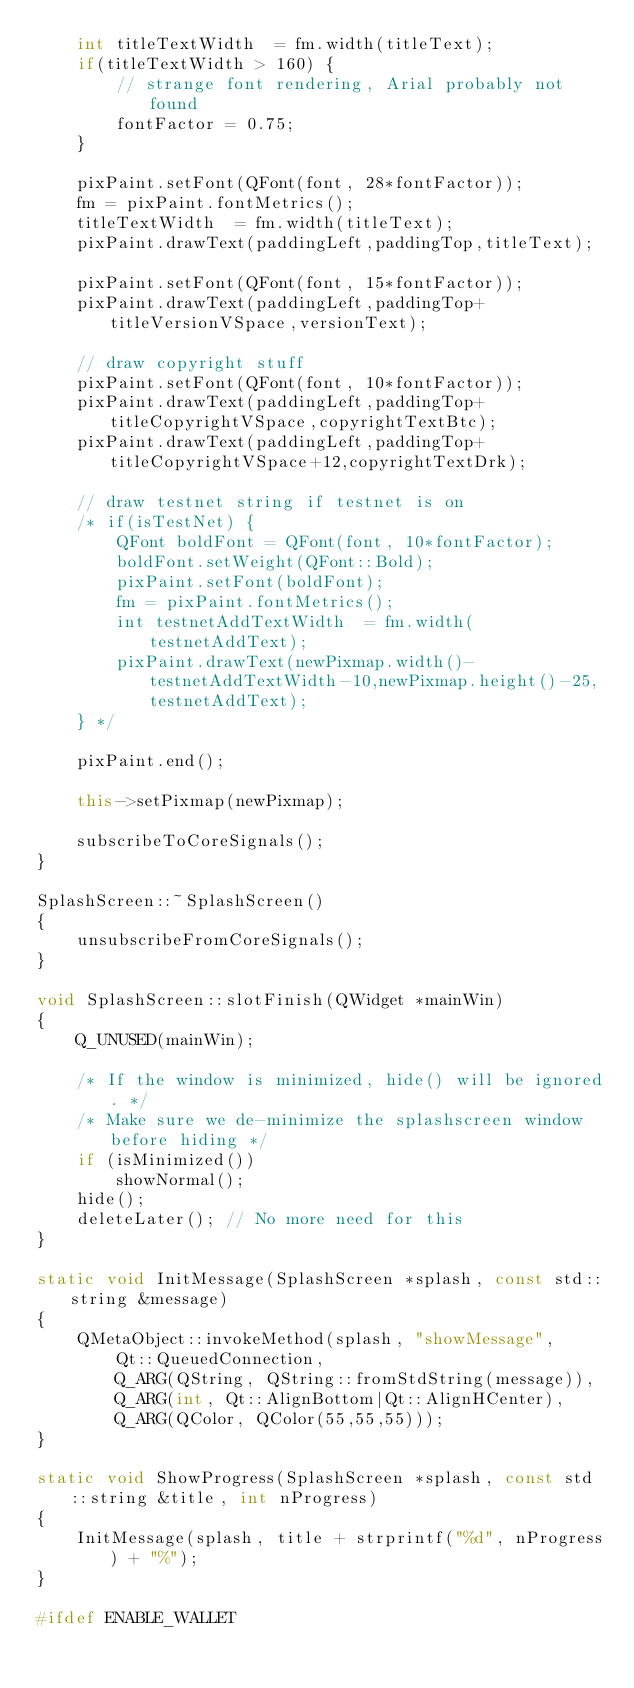<code> <loc_0><loc_0><loc_500><loc_500><_C++_>    int titleTextWidth  = fm.width(titleText);
    if(titleTextWidth > 160) {
        // strange font rendering, Arial probably not found
        fontFactor = 0.75;
    }

    pixPaint.setFont(QFont(font, 28*fontFactor));
    fm = pixPaint.fontMetrics();
    titleTextWidth  = fm.width(titleText);
    pixPaint.drawText(paddingLeft,paddingTop,titleText);

    pixPaint.setFont(QFont(font, 15*fontFactor));
    pixPaint.drawText(paddingLeft,paddingTop+titleVersionVSpace,versionText);

    // draw copyright stuff
    pixPaint.setFont(QFont(font, 10*fontFactor));
    pixPaint.drawText(paddingLeft,paddingTop+titleCopyrightVSpace,copyrightTextBtc);
    pixPaint.drawText(paddingLeft,paddingTop+titleCopyrightVSpace+12,copyrightTextDrk);

    // draw testnet string if testnet is on
    /* if(isTestNet) {
        QFont boldFont = QFont(font, 10*fontFactor);
        boldFont.setWeight(QFont::Bold);
        pixPaint.setFont(boldFont);
        fm = pixPaint.fontMetrics();
        int testnetAddTextWidth  = fm.width(testnetAddText);
        pixPaint.drawText(newPixmap.width()-testnetAddTextWidth-10,newPixmap.height()-25,testnetAddText);
    } */

    pixPaint.end();

    this->setPixmap(newPixmap);

    subscribeToCoreSignals();
}

SplashScreen::~SplashScreen()
{
    unsubscribeFromCoreSignals();
}

void SplashScreen::slotFinish(QWidget *mainWin)
{
    Q_UNUSED(mainWin);

    /* If the window is minimized, hide() will be ignored. */
    /* Make sure we de-minimize the splashscreen window before hiding */
    if (isMinimized())
        showNormal();
    hide();
    deleteLater(); // No more need for this
}

static void InitMessage(SplashScreen *splash, const std::string &message)
{
    QMetaObject::invokeMethod(splash, "showMessage",
        Qt::QueuedConnection,
        Q_ARG(QString, QString::fromStdString(message)),
        Q_ARG(int, Qt::AlignBottom|Qt::AlignHCenter),
        Q_ARG(QColor, QColor(55,55,55)));
}

static void ShowProgress(SplashScreen *splash, const std::string &title, int nProgress)
{
    InitMessage(splash, title + strprintf("%d", nProgress) + "%");
}

#ifdef ENABLE_WALLET</code> 